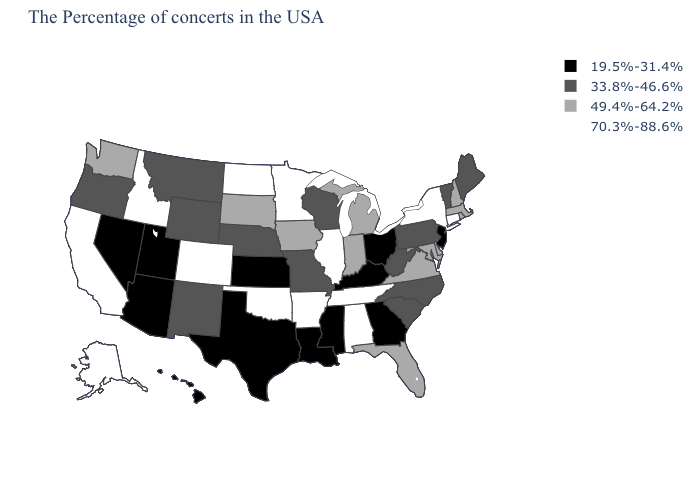Does Texas have the same value as Utah?
Quick response, please. Yes. Which states hav the highest value in the MidWest?
Write a very short answer. Illinois, Minnesota, North Dakota. Which states have the lowest value in the West?
Short answer required. Utah, Arizona, Nevada, Hawaii. What is the lowest value in states that border South Carolina?
Write a very short answer. 19.5%-31.4%. Name the states that have a value in the range 70.3%-88.6%?
Concise answer only. Connecticut, New York, Alabama, Tennessee, Illinois, Arkansas, Minnesota, Oklahoma, North Dakota, Colorado, Idaho, California, Alaska. Does Mississippi have the lowest value in the USA?
Give a very brief answer. Yes. Is the legend a continuous bar?
Keep it brief. No. What is the value of Alabama?
Concise answer only. 70.3%-88.6%. Does Tennessee have the highest value in the South?
Answer briefly. Yes. Name the states that have a value in the range 33.8%-46.6%?
Be succinct. Maine, Vermont, Pennsylvania, North Carolina, South Carolina, West Virginia, Wisconsin, Missouri, Nebraska, Wyoming, New Mexico, Montana, Oregon. Name the states that have a value in the range 49.4%-64.2%?
Answer briefly. Massachusetts, Rhode Island, New Hampshire, Delaware, Maryland, Virginia, Florida, Michigan, Indiana, Iowa, South Dakota, Washington. Name the states that have a value in the range 70.3%-88.6%?
Give a very brief answer. Connecticut, New York, Alabama, Tennessee, Illinois, Arkansas, Minnesota, Oklahoma, North Dakota, Colorado, Idaho, California, Alaska. Among the states that border North Dakota , which have the lowest value?
Keep it brief. Montana. What is the value of Michigan?
Answer briefly. 49.4%-64.2%. What is the value of Iowa?
Be succinct. 49.4%-64.2%. 